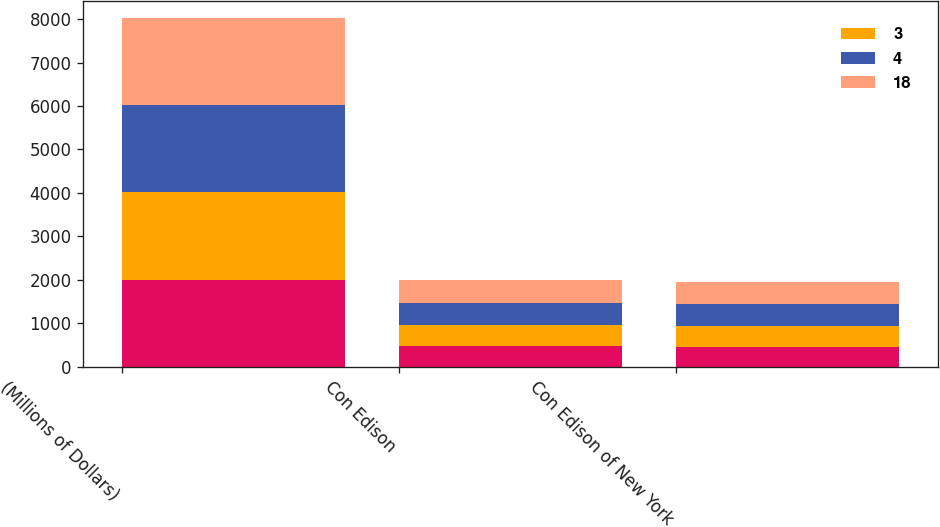<chart> <loc_0><loc_0><loc_500><loc_500><stacked_bar_chart><ecel><fcel>(Millions of Dollars)<fcel>Con Edison<fcel>Con Edison of New York<nl><fcel>nan<fcel>2005<fcel>470<fcel>452<nl><fcel>3<fcel>2006<fcel>493<fcel>488<nl><fcel>4<fcel>2007<fcel>512<fcel>508<nl><fcel>18<fcel>2008<fcel>514<fcel>511<nl></chart> 